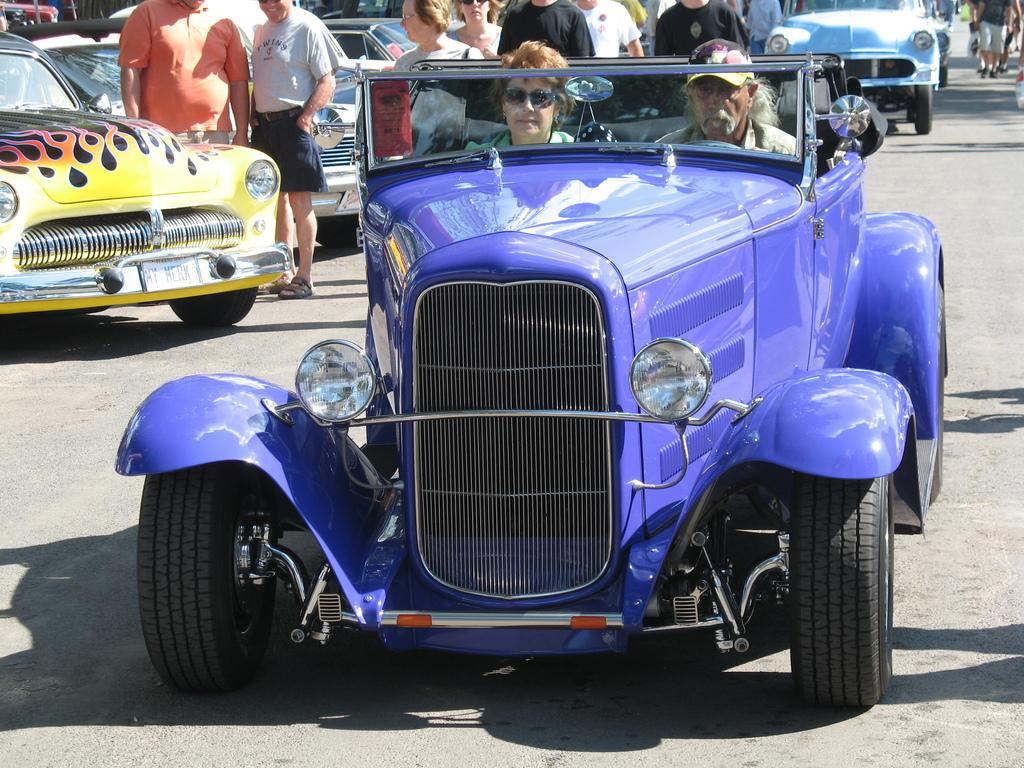How many people are in the vehicle in the image? There are two people in a blue vehicle in the image. What else can be seen in the background of the image? There are other people and vehicles visible in the background. What type of ball is being used by the people in the vehicle? There is no ball present in the image; it features a blue vehicle with two people inside and other people and vehicles in the background. 